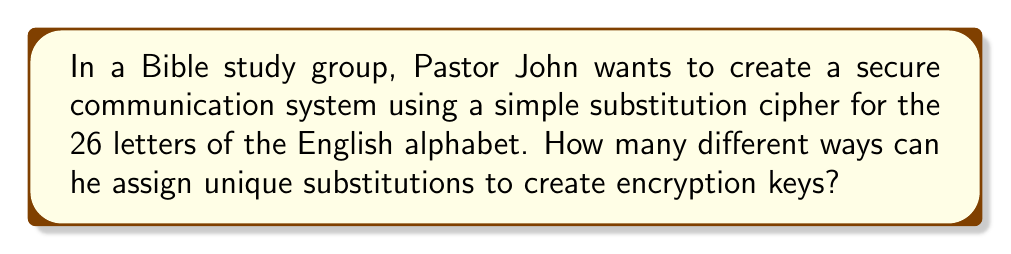Can you solve this math problem? Let's approach this step-by-step:

1) In a simple substitution cipher, each letter of the alphabet is replaced by another letter, and no two letters can be replaced by the same letter.

2) For the first letter, Pastor John has 26 choices.

3) For the second letter, he has 25 remaining choices, as one letter has already been used.

4) For the third letter, he has 24 choices, and so on.

5) This continues until he assigns the last letter, where he has only 1 choice left.

6) Mathematically, this is represented by the product:

   $$26 \times 25 \times 24 \times 23 \times ... \times 2 \times 1$$

7) This is the definition of 26 factorial, written as 26!

8) Therefore, the number of possible encryption keys is 26!

9) Calculating this:
   $$26! = 403,291,461,126,605,635,584,000,000$$

This large number demonstrates the strength of even a simple substitution cipher, showing how God's design of mathematics can be used to protect righteous communication.
Answer: 26! 